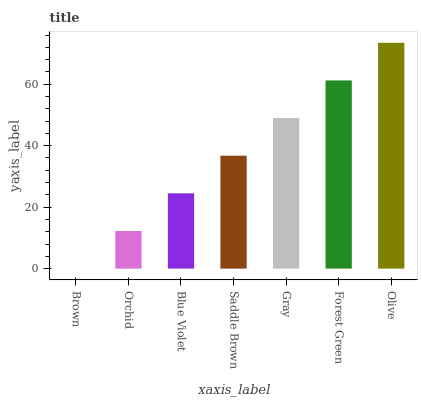Is Brown the minimum?
Answer yes or no. Yes. Is Olive the maximum?
Answer yes or no. Yes. Is Orchid the minimum?
Answer yes or no. No. Is Orchid the maximum?
Answer yes or no. No. Is Orchid greater than Brown?
Answer yes or no. Yes. Is Brown less than Orchid?
Answer yes or no. Yes. Is Brown greater than Orchid?
Answer yes or no. No. Is Orchid less than Brown?
Answer yes or no. No. Is Saddle Brown the high median?
Answer yes or no. Yes. Is Saddle Brown the low median?
Answer yes or no. Yes. Is Gray the high median?
Answer yes or no. No. Is Olive the low median?
Answer yes or no. No. 